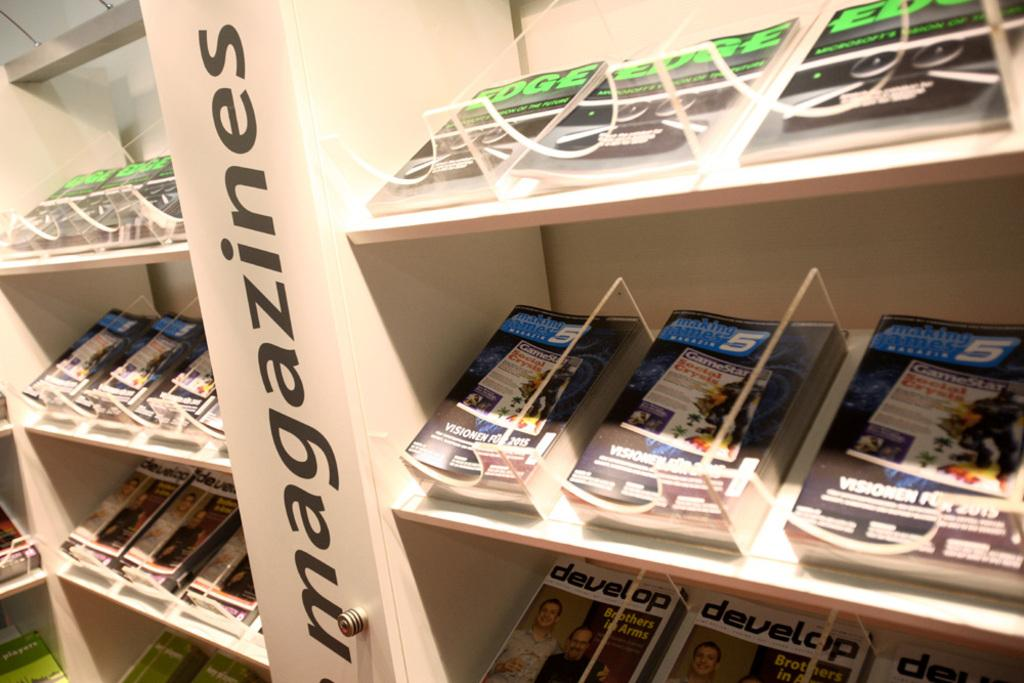What is the main object in the image? There is a rack in the image. What is stored on the rack? Books are placed in the rack. What type of discussion is taking place in the image? There is no discussion taking place in the image; it only shows a rack with books. How many bulbs are visible in the image? There are no bulbs visible in the image; it only shows a rack with books. 